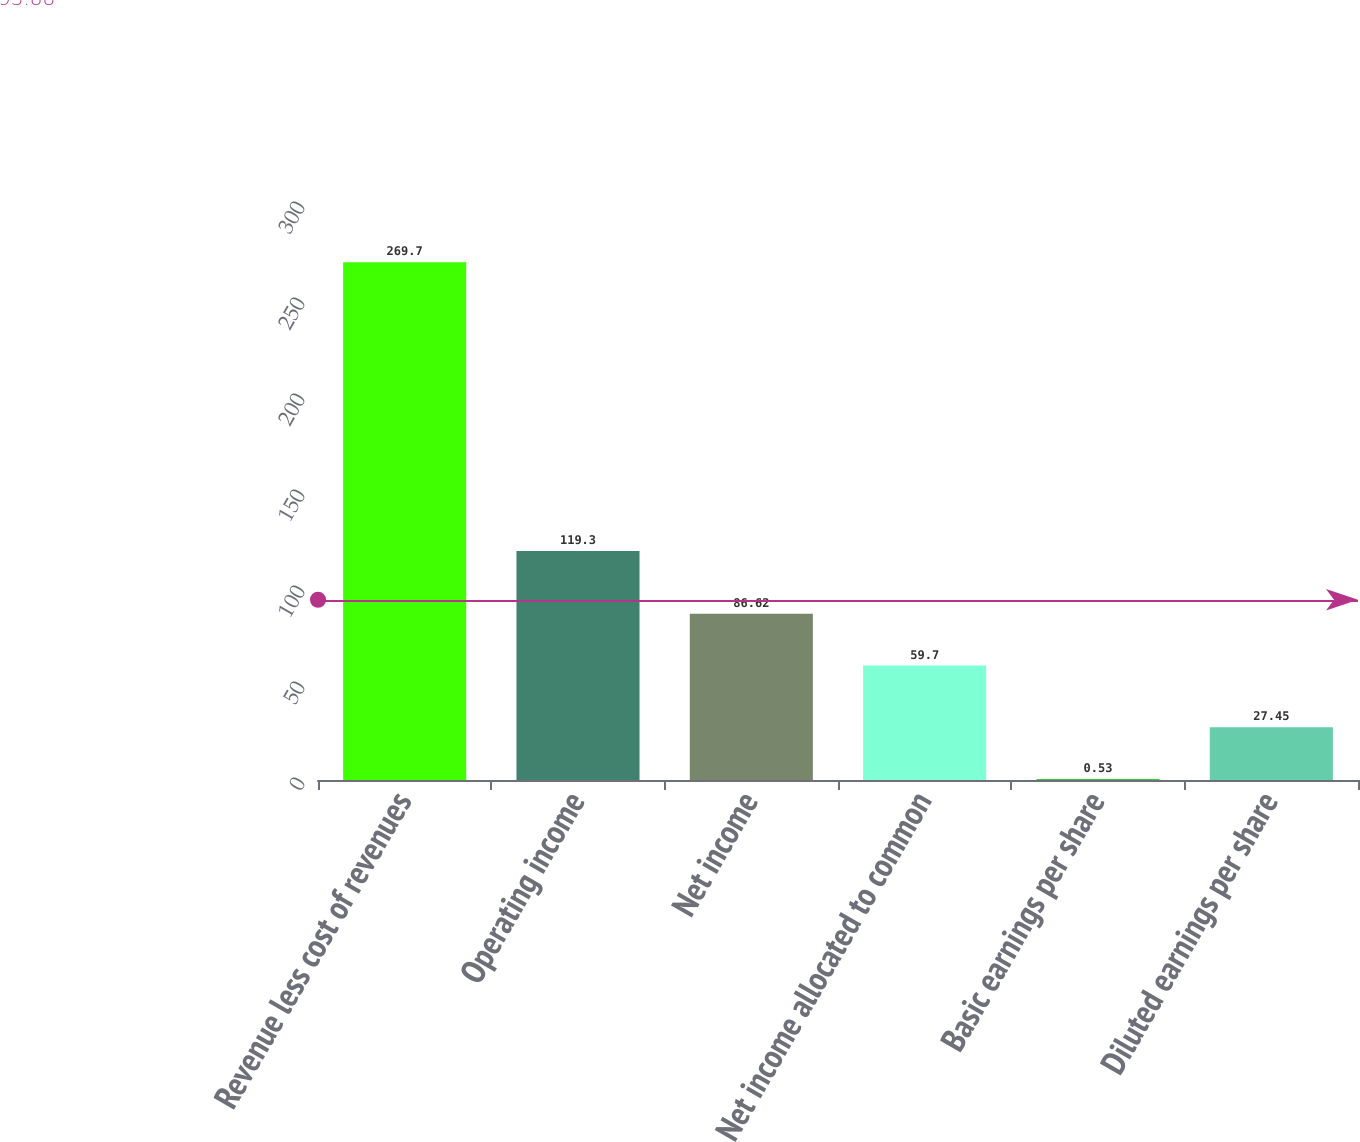Convert chart. <chart><loc_0><loc_0><loc_500><loc_500><bar_chart><fcel>Revenue less cost of revenues<fcel>Operating income<fcel>Net income<fcel>Net income allocated to common<fcel>Basic earnings per share<fcel>Diluted earnings per share<nl><fcel>269.7<fcel>119.3<fcel>86.62<fcel>59.7<fcel>0.53<fcel>27.45<nl></chart> 